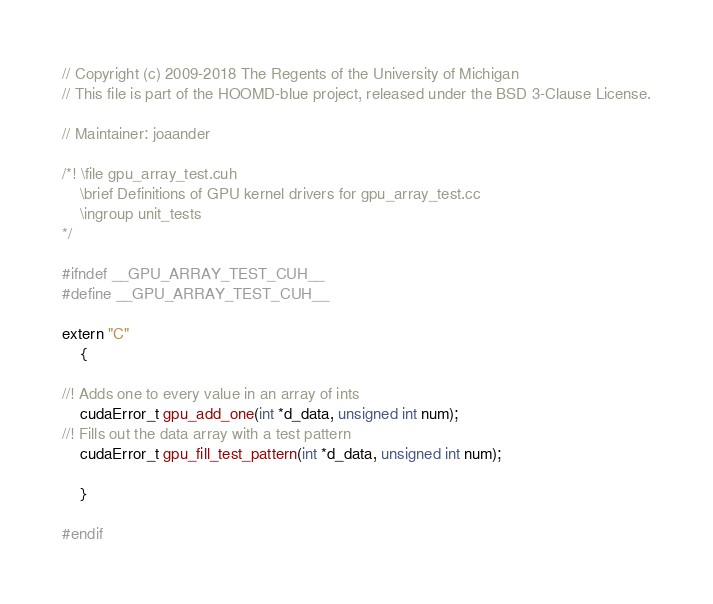<code> <loc_0><loc_0><loc_500><loc_500><_Cuda_>// Copyright (c) 2009-2018 The Regents of the University of Michigan
// This file is part of the HOOMD-blue project, released under the BSD 3-Clause License.

// Maintainer: joaander

/*! \file gpu_array_test.cuh
    \brief Definitions of GPU kernel drivers for gpu_array_test.cc
    \ingroup unit_tests
*/

#ifndef __GPU_ARRAY_TEST_CUH__
#define __GPU_ARRAY_TEST_CUH__

extern "C"
    {

//! Adds one to every value in an array of ints
    cudaError_t gpu_add_one(int *d_data, unsigned int num);
//! Fills out the data array with a test pattern
    cudaError_t gpu_fill_test_pattern(int *d_data, unsigned int num);

    }

#endif
</code> 